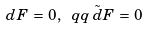Convert formula to latex. <formula><loc_0><loc_0><loc_500><loc_500>d F \, = \, 0 , \ q q \, { \tilde { d } } F \, = \, 0</formula> 